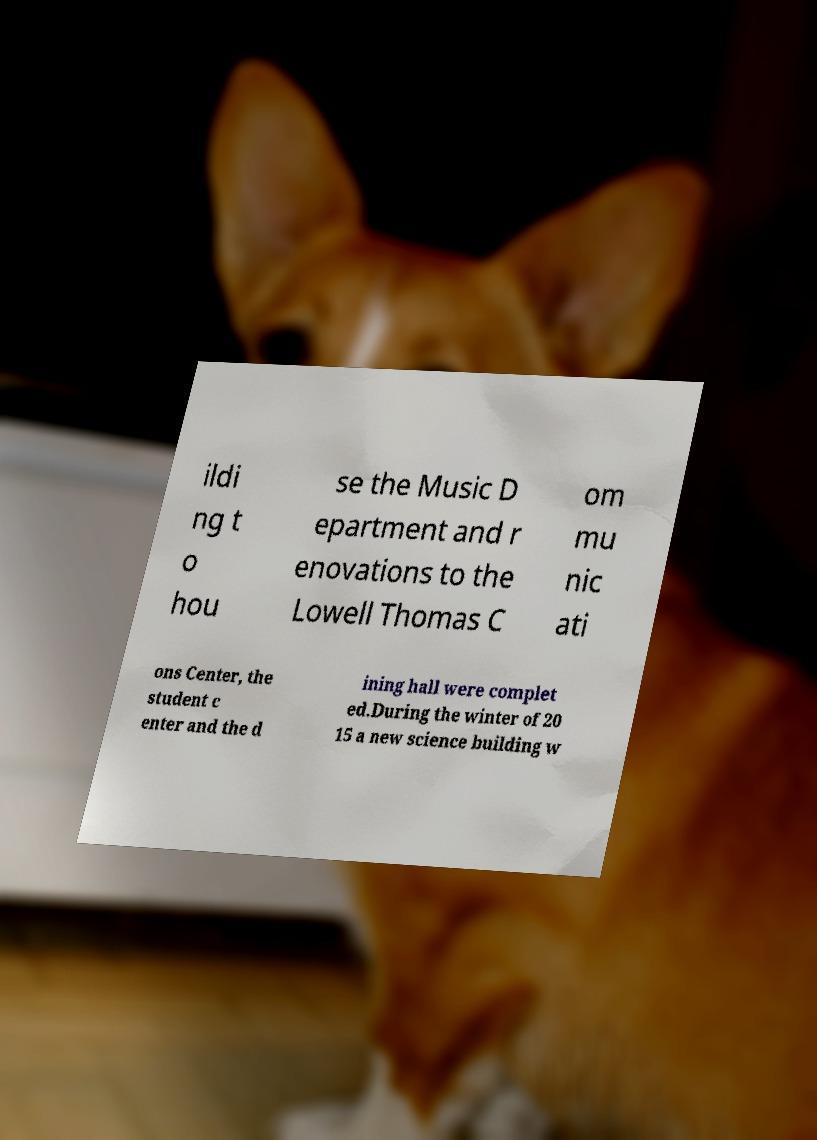What messages or text are displayed in this image? I need them in a readable, typed format. ildi ng t o hou se the Music D epartment and r enovations to the Lowell Thomas C om mu nic ati ons Center, the student c enter and the d ining hall were complet ed.During the winter of 20 15 a new science building w 